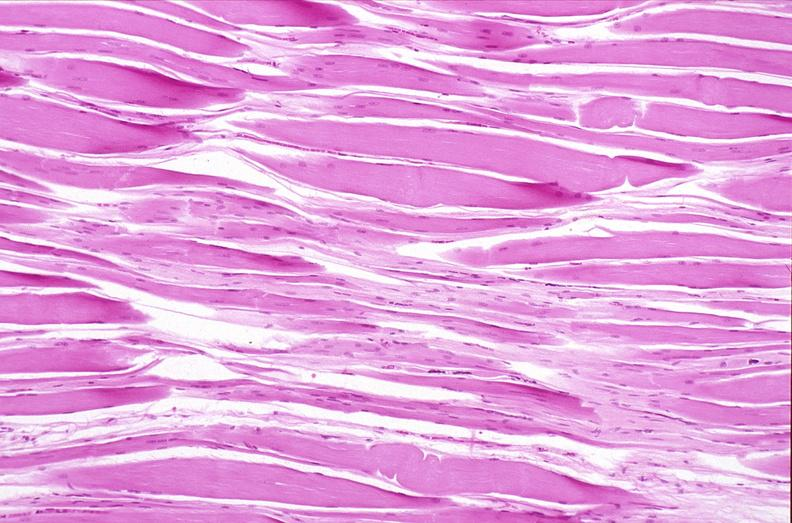s musculoskeletal present?
Answer the question using a single word or phrase. Yes 